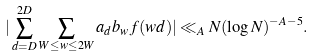Convert formula to latex. <formula><loc_0><loc_0><loc_500><loc_500>| \sum _ { d = D } ^ { 2 D } \sum _ { W \leq w \leq 2 W } a _ { d } b _ { w } f ( w d ) | \ll _ { A } N ( \log N ) ^ { - A - 5 } .</formula> 